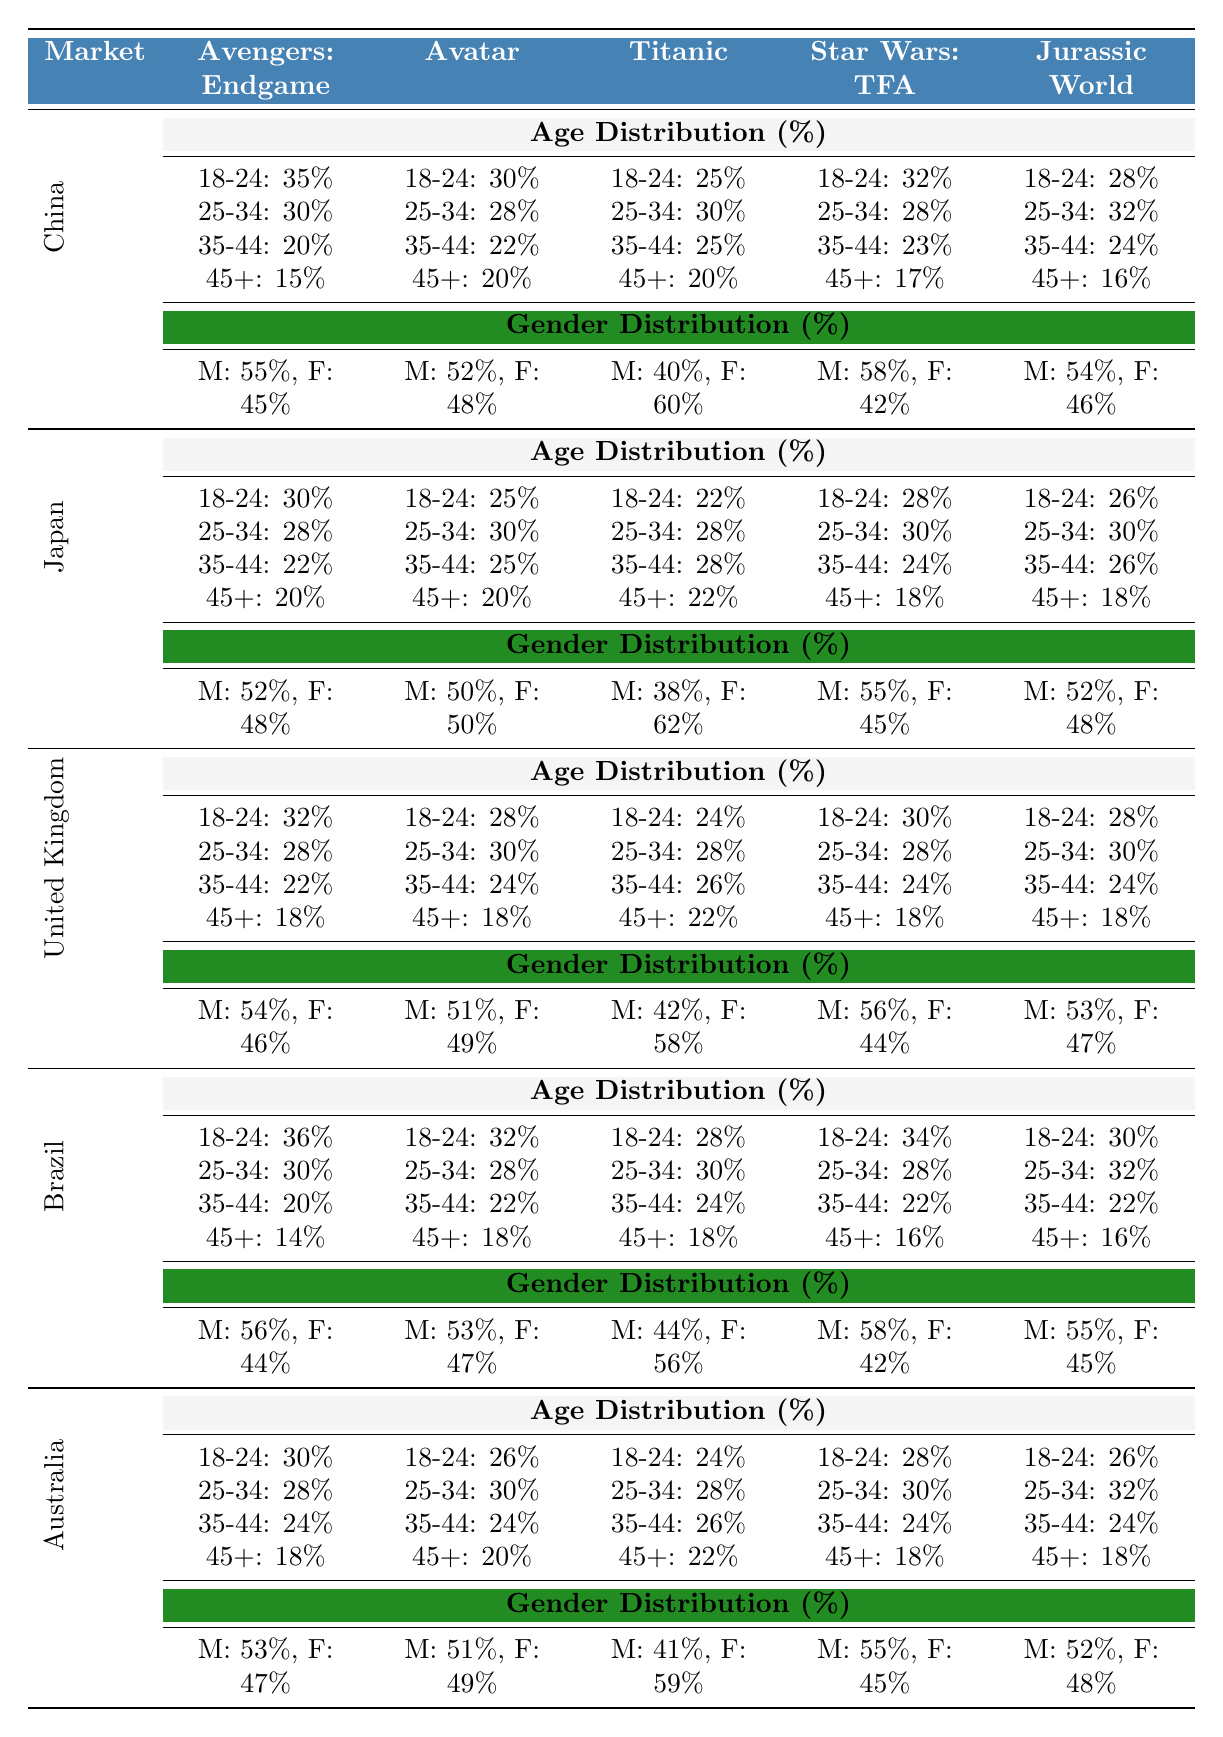What is the percentage of males who watched "Avatar" in the United Kingdom? The gender distribution for "Avatar" in the United Kingdom is male: 51%, female: 49%. Therefore, the percentage of males is 51%.
Answer: 51% Which film had the highest percentage of 18-24 year-olds in Brazil? In Brazil, "Avengers: Endgame" had the highest percentage of 18-24 year-olds at 36%.
Answer: "Avengers: Endgame" Is the gender distribution for "Titanic" in Japan equal? For "Titanic" in Japan, the distribution is male: 38% and female: 62%, which is not equal.
Answer: No What is the average percentage of 25-34 year-olds across all films in China? The percentages for 25-34 year-olds in China are: Avengers: Endgame 30%, Avatar 28%, Titanic 30%, Star Wars: The Force Awakens 28%, Jurassic World 32%. Summing these gives 30 + 28 + 30 + 28 + 32 = 148. Dividing by 5 gives an average of 148/5 = 29.6%.
Answer: 29.6% In which market did "Jurassic World" receive a higher percentage of tickets sold to females than males? For "Titanic" in China (60% female) and Brazil (56% female), females outnumbered males. In Japan, "Titanic" also had 62% female.
Answer: China and Brazil Which film was most popular among males aged 18-24 in South Korea? The data does not explicitly include South Korea, but if we assume a similar trend to the other markets, one could estimate popularity based on other markets and films like "Avengers: Endgame" which was prevalent in similar demographics previously. However, specific ratios are needed to confirm that.
Answer: Not available in the data What is the percentage of 35-44 year-olds for "Star Wars: The Force Awakens" in Japan? The table specifies that for "Star Wars: The Force Awakens" in Japan, 35-44 year-olds accounted for 24%.
Answer: 24% In which country did "Avengers: Endgame" have a lower percentage of 45+ year-olds compared to "Jurassic World"? For "Avengers: Endgame" in Brazil, it was 14%, and for "Jurassic World," the percentage was 16%. This indicates Avengers: Endgame had a lower percentage.
Answer: Brazil What is the percentage of 18-24 year-olds who watched "Titanic" in Australia? The table indicates that in Australia, the percentage of 18-24 year-olds who watched "Titanic" is 24%.
Answer: 24% Which film had the highest attendance from males in Japan? Among the films in Japan, "Star Wars: The Force Awakens" had the highest male attendance at 55%.
Answer: "Star Wars: The Force Awakens" What is the difference in percentage between female and male attendees for "Avatar" in Germany? The data indicates that for "Avatar," males accounted for 50% and females for 50%. The difference in percentage, therefore, is 0%.
Answer: 0% 